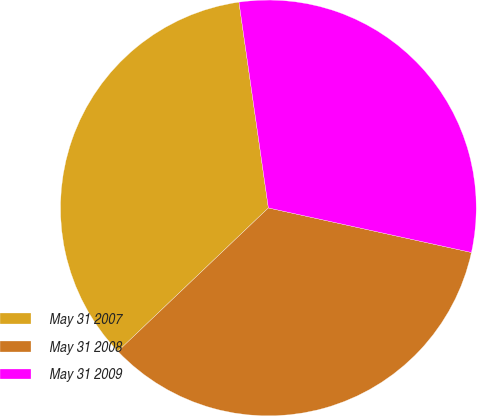<chart> <loc_0><loc_0><loc_500><loc_500><pie_chart><fcel>May 31 2007<fcel>May 31 2008<fcel>May 31 2009<nl><fcel>34.86%<fcel>34.45%<fcel>30.7%<nl></chart> 